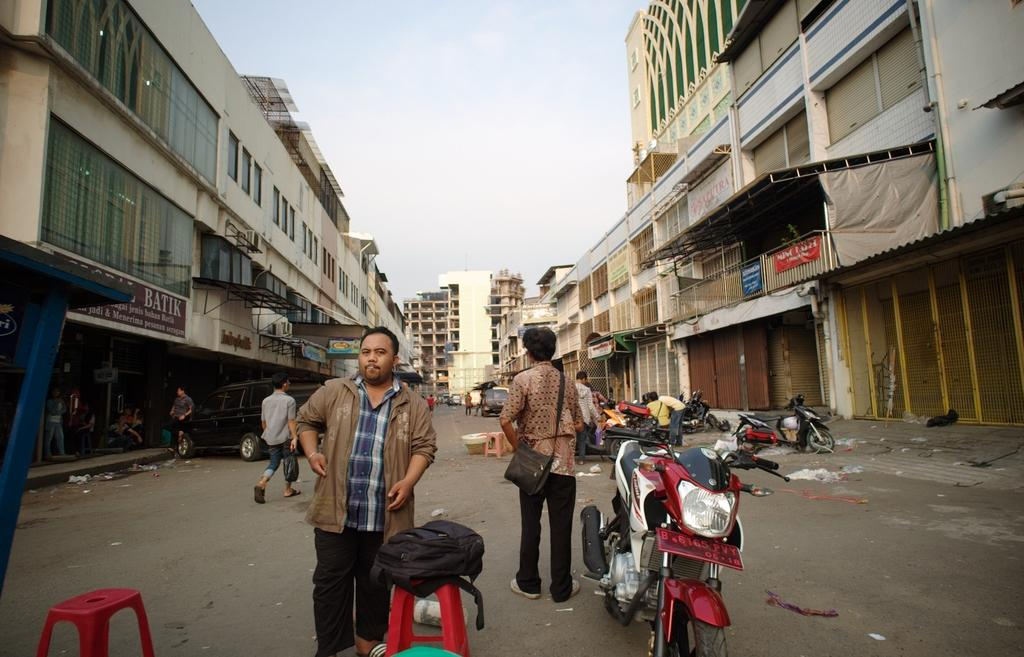What types of subjects can be seen in the image? There are people and vehicles in the image. What type of furniture is present in the image? There are stools in the image. What is on the ground in the image? There are objects on the ground in the image. What can be seen in the distance in the image? There are buildings in the background of the image, and the sky is visible in the background as well. What sounds can be heard coming from the ground in the image? There is no information about sounds in the image, as it only provides visual information. 